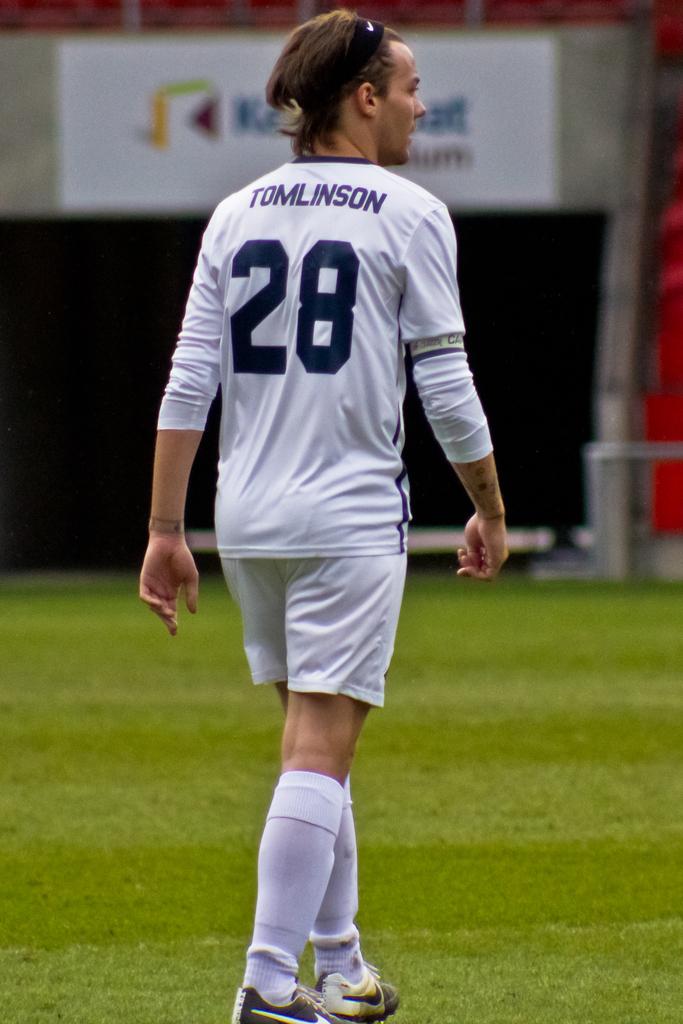What number is this player on his team?
Your answer should be compact. 28. What is the players name?
Give a very brief answer. Tomlinson. 